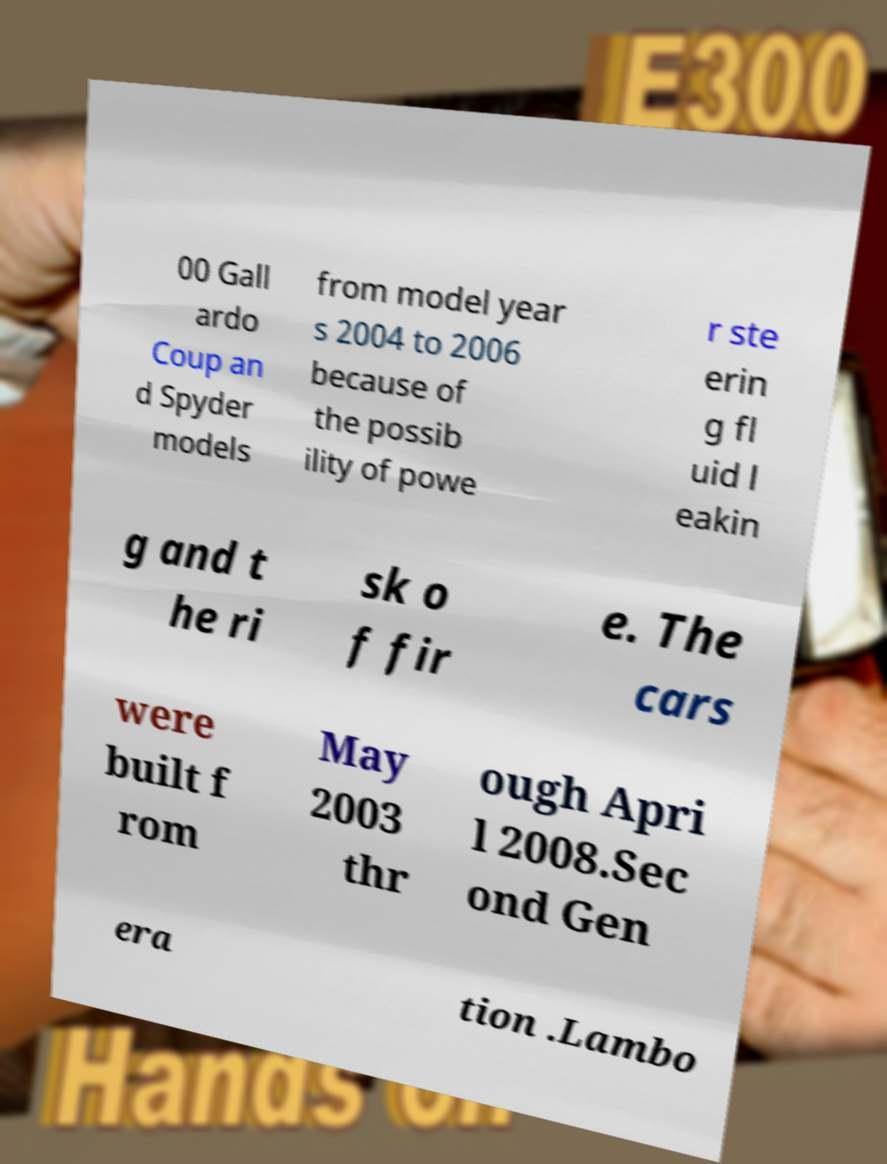What messages or text are displayed in this image? I need them in a readable, typed format. 00 Gall ardo Coup an d Spyder models from model year s 2004 to 2006 because of the possib ility of powe r ste erin g fl uid l eakin g and t he ri sk o f fir e. The cars were built f rom May 2003 thr ough Apri l 2008.Sec ond Gen era tion .Lambo 